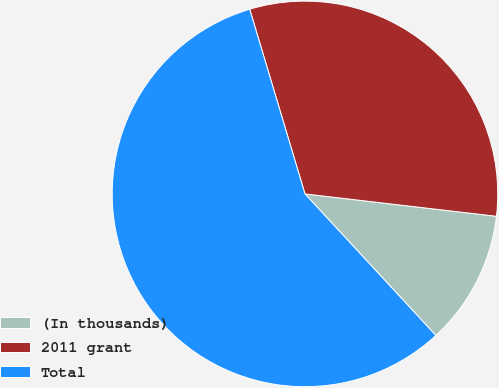Convert chart. <chart><loc_0><loc_0><loc_500><loc_500><pie_chart><fcel>(In thousands)<fcel>2011 grant<fcel>Total<nl><fcel>11.27%<fcel>31.48%<fcel>57.25%<nl></chart> 